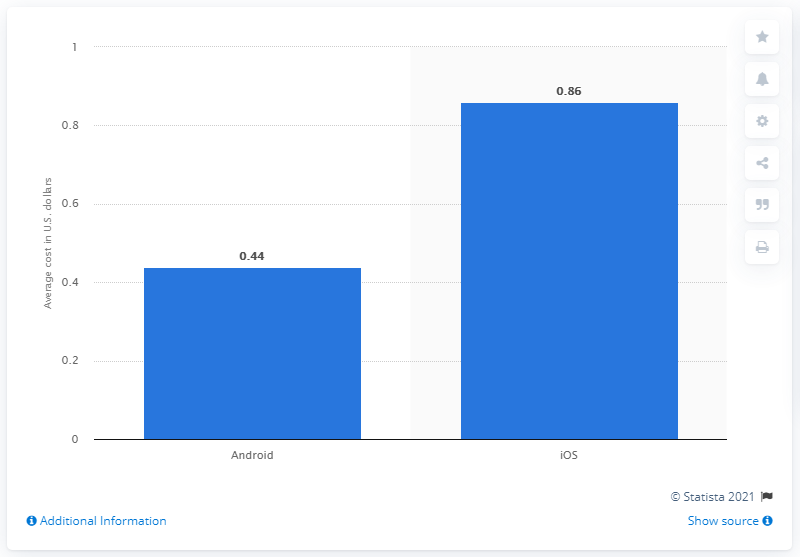Outline some significant characteristics in this image. The average cost per install (CPI) for Android apps during the measured period was 0.44. 